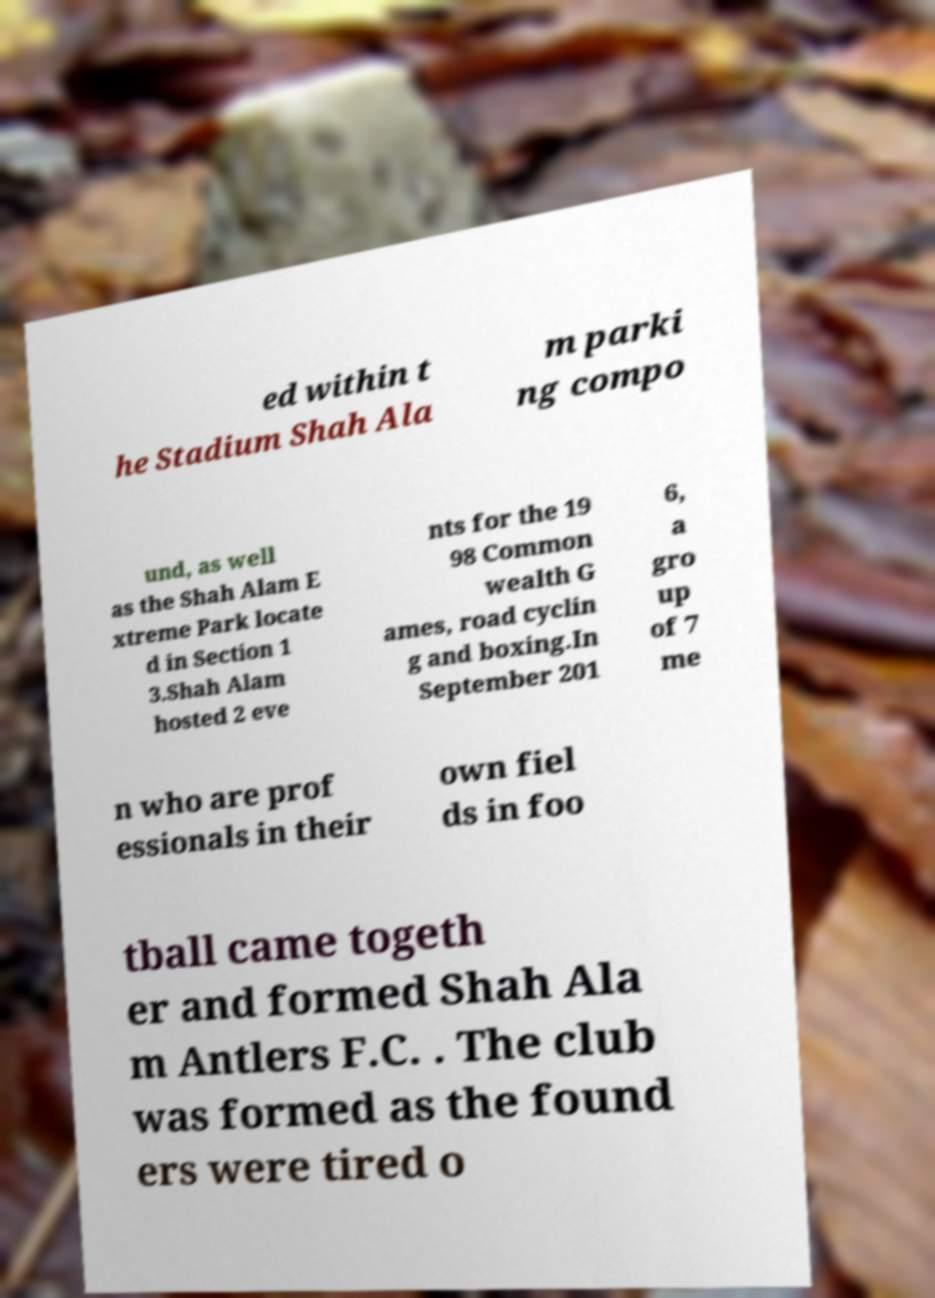Can you read and provide the text displayed in the image?This photo seems to have some interesting text. Can you extract and type it out for me? ed within t he Stadium Shah Ala m parki ng compo und, as well as the Shah Alam E xtreme Park locate d in Section 1 3.Shah Alam hosted 2 eve nts for the 19 98 Common wealth G ames, road cyclin g and boxing.In September 201 6, a gro up of 7 me n who are prof essionals in their own fiel ds in foo tball came togeth er and formed Shah Ala m Antlers F.C. . The club was formed as the found ers were tired o 